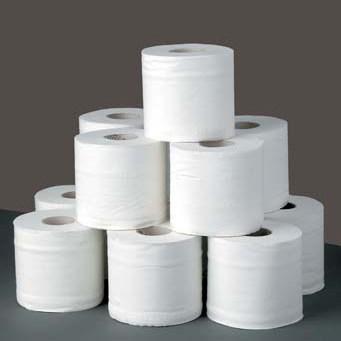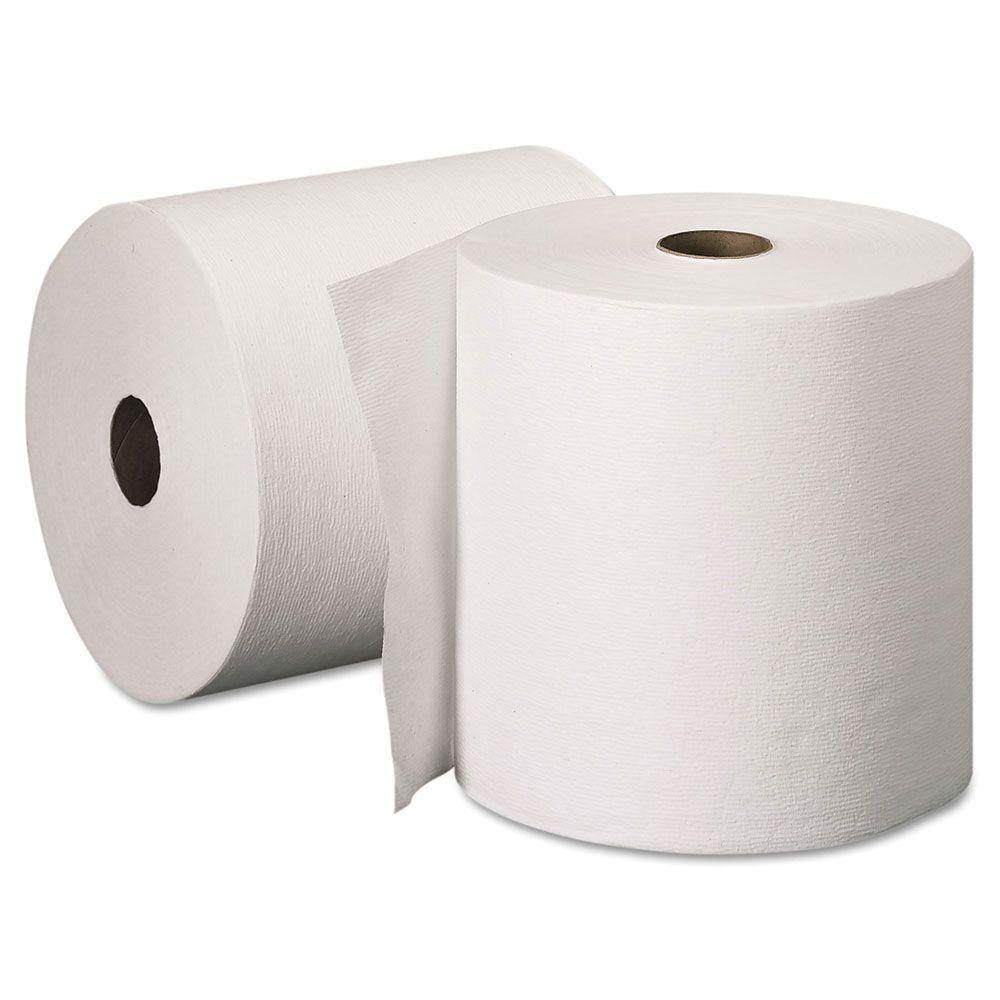The first image is the image on the left, the second image is the image on the right. Given the left and right images, does the statement "There is exactly one roll of paper towels in the image on the left." hold true? Answer yes or no. No. 